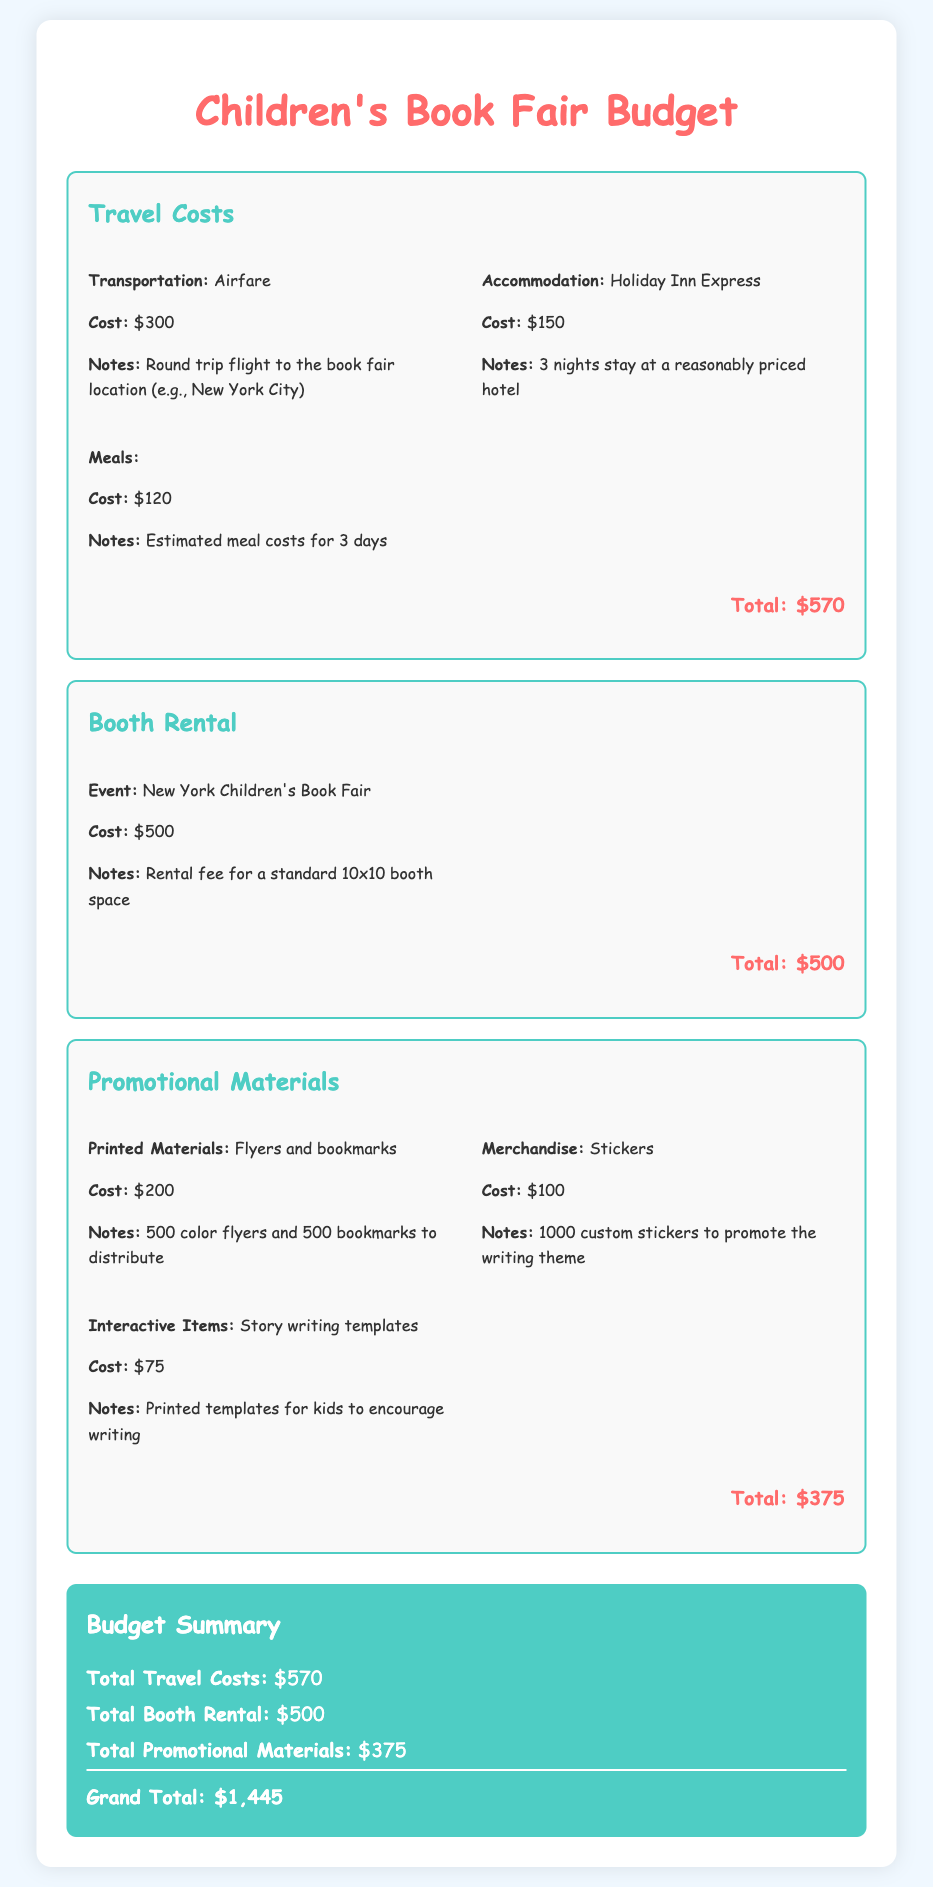What is the total cost for travel? The total cost for travel is stated in the document under the travel costs section, which sums up to $570.
Answer: $570 What is the cost for booth rental? The document specifies the cost for booth rental for the event as $500.
Answer: $500 How much is allocated for promotional materials? The total allocated for promotional materials is detailed in the document as $375.
Answer: $375 How many nights of accommodation is included in the budget? The budget states that accommodation is for 3 nights at a hotel.
Answer: 3 nights What is the cost of printed materials for promotion? The document lists the cost of printed materials, including flyers and bookmarks, as $200.
Answer: $200 What is the grand total of the budget? The grand total of the budget is presented at the end of the document, totaling $1,445.
Answer: $1,445 What type of booth is rented at the book fair? The type of booth rented is described in the document as a standard 10x10 booth space.
Answer: standard 10x10 booth space What types of promotional items are included in the budget? The document mentions several promotional items, including flyers, bookmarks, stickers, and writing templates.
Answer: flyers, bookmarks, stickers, writing templates What is the estimated meal cost for the trip? The estimated meal cost for the trip is stated as $120 under the travel costs section.
Answer: $120 